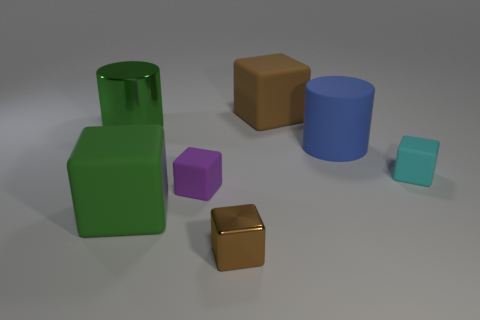Subtract all large brown rubber cubes. How many cubes are left? 4 Subtract all purple blocks. How many blocks are left? 4 Add 1 brown blocks. How many objects exist? 8 Subtract all cyan blocks. Subtract all green cylinders. How many blocks are left? 4 Subtract all cylinders. How many objects are left? 5 Subtract all tiny blocks. Subtract all rubber cylinders. How many objects are left? 3 Add 1 large metal things. How many large metal things are left? 2 Add 5 small purple matte objects. How many small purple matte objects exist? 6 Subtract 1 green blocks. How many objects are left? 6 